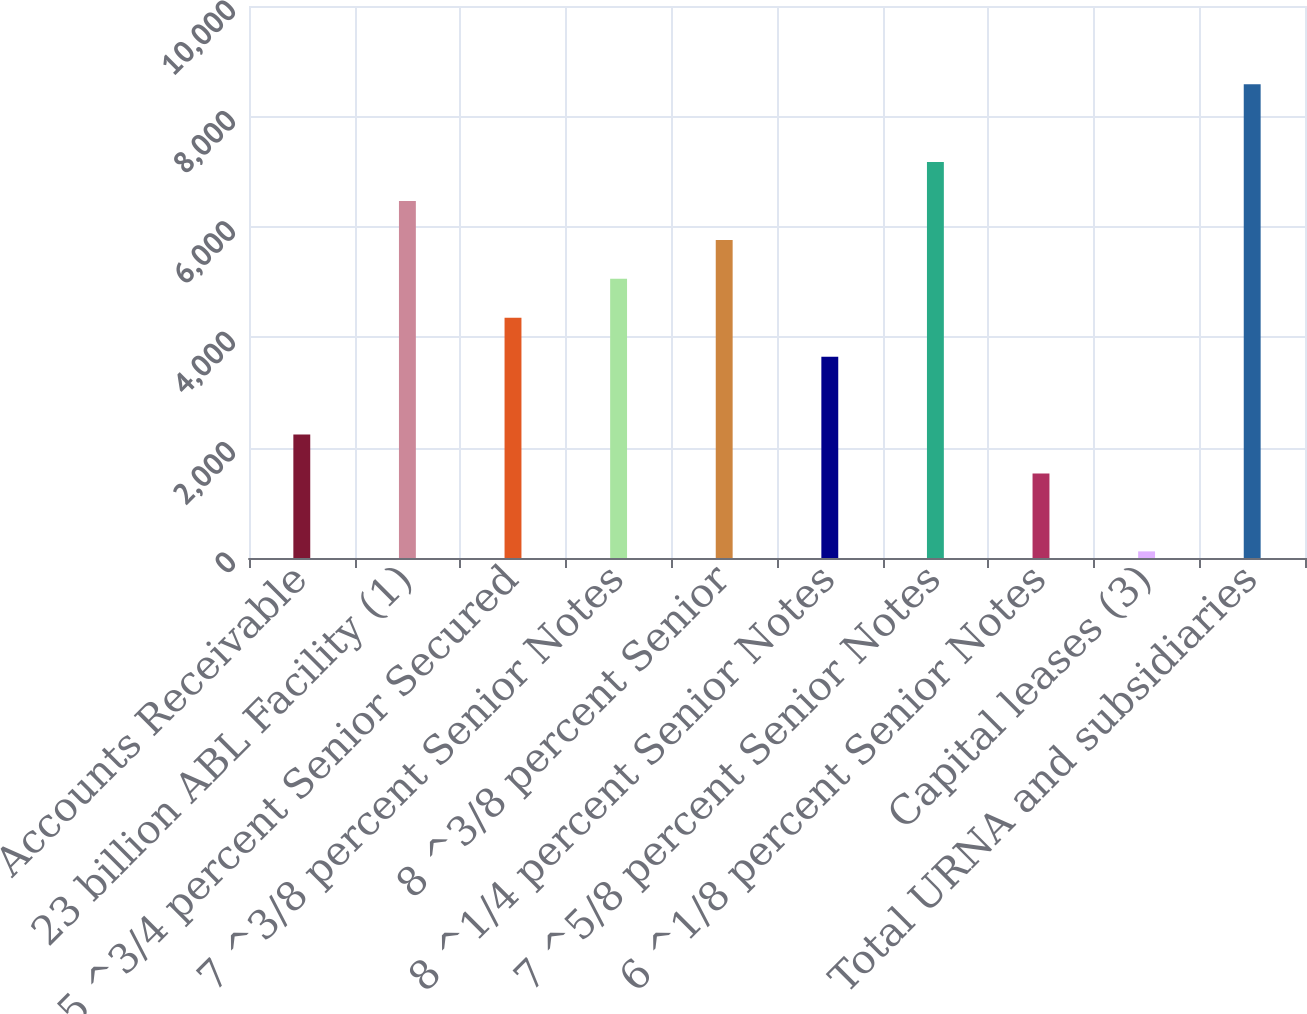<chart> <loc_0><loc_0><loc_500><loc_500><bar_chart><fcel>Accounts Receivable<fcel>23 billion ABL Facility (1)<fcel>5 ^3/4 percent Senior Secured<fcel>7 ^3/8 percent Senior Notes<fcel>8 ^3/8 percent Senior<fcel>8 ^1/4 percent Senior Notes<fcel>7 ^5/8 percent Senior Notes<fcel>6 ^1/8 percent Senior Notes<fcel>Capital leases (3)<fcel>Total URNA and subsidiaries<nl><fcel>2235.9<fcel>6467.7<fcel>4351.8<fcel>5057.1<fcel>5762.4<fcel>3646.5<fcel>7173<fcel>1530.6<fcel>120<fcel>8583.6<nl></chart> 